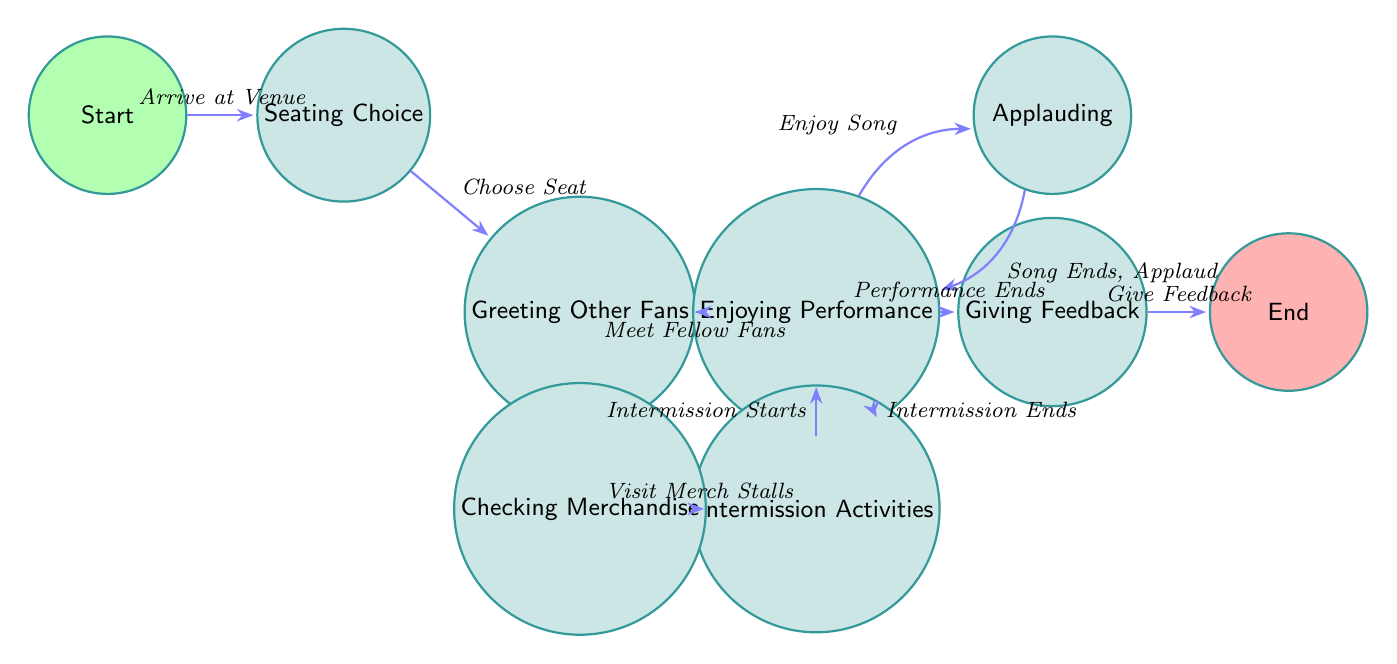What is the starting node of the diagram? The starting node of the diagram is labeled "Start". This node represents the initial state from which the attendee engagement process begins.
Answer: Start How many nodes are in the diagram? To find the total number of nodes, we need to count them listed in the "nodes" section of the data. There are nine nodes in total: Start, Seating Choice, Greeting Other Fans, Enjoying Performance, Applauding, Intermission Activities, Checking Merchandise, Giving Feedback, and End.
Answer: Nine What action leads from "Seating Choice" to "Greeting Other Fans"? The action leading from "Seating Choice" to "Greeting Other Fans" is labeled as "Choose Seat". This action takes place after the attendee has selected their seat and then proceeds to greet fellow fans.
Answer: Choose Seat Which nodes are directly connected to "Intermission Activities"? The nodes directly connected to "Intermission Activities" are "Performance" and "Checking Merchandise". This means after intermission activities, attendees can either return to the performance or go check merchandise.
Answer: Performance, Checking Merchandise What happens after "Enjoying Performance"? After "Enjoying Performance", if an intermission starts, the next node is "Intermission Activities". This step indicates that the performance may transition into a break for attendees.
Answer: Intermission Activities How many transitions lead to the "End" node? There is only one transition that leads to the "End" node, which occurs after the node "Giving Feedback." This means that the process concludes after feedback is given.
Answer: One What is the transition from "Performance" during an intermission? The transition from "Performance" during an intermission is labeled "Intermission Starts". This signifies the time when the performance is paused, and intermission activities commence.
Answer: Intermission Starts What occurs after "Applauding"? After "Applauding", the next possible action is "Enjoy Song", indicating the continuous cycle of enjoying songs and applauding after each performance.
Answer: Enjoy Song In what state does the performance end? The performance ends in the "Giving Feedback" state. This marks the conclusion of the engagement actions at the performance, where attendees can share their thoughts.
Answer: Giving Feedback 